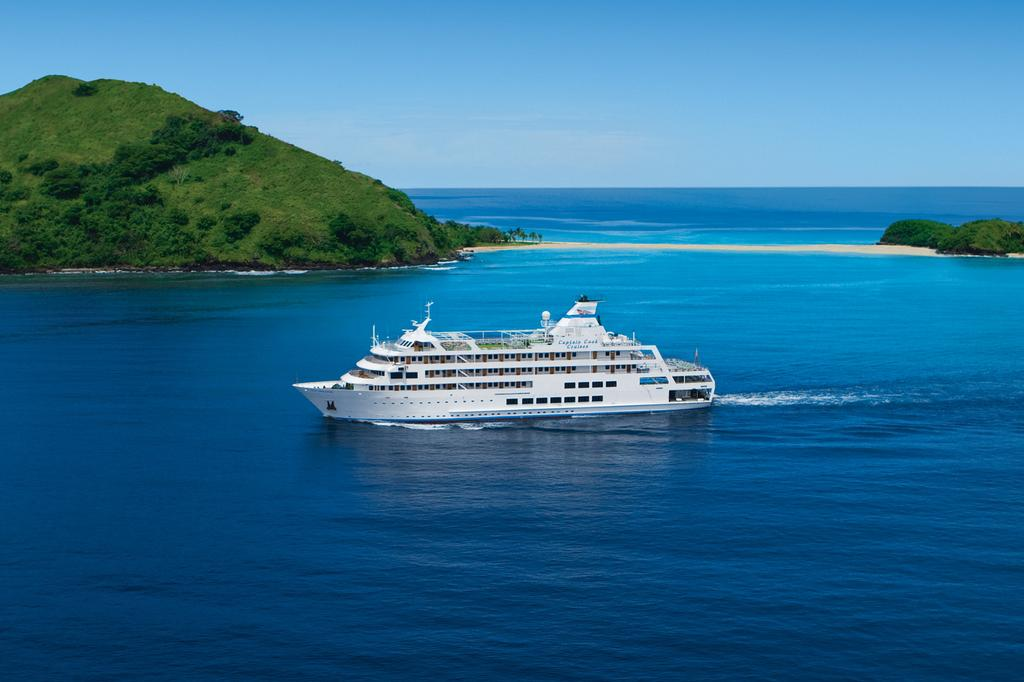What is the main subject in the middle of the image? There is a boat in the middle of the image. Where is the boat located? The boat is in the water. What can be seen in the background of the image? There are trees, mountains, and the sky visible in the background of the image. What type of water might the boat be in? The image may have been taken in the ocean. Can you see any grains of sand being carried by the ants in the image? There are no ants or grains of sand present in the image. What is the topic of the argument taking place in the image? There is no argument present in the image; it features a boat in the water with a background of trees, mountains, and the sky. 